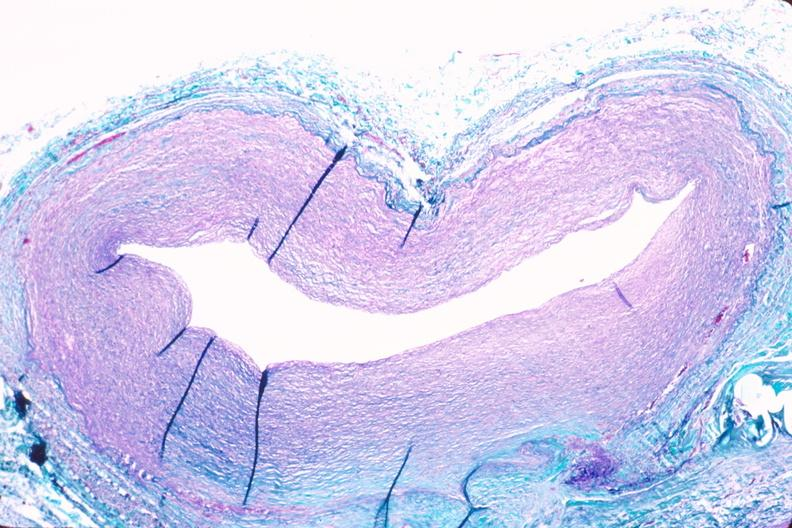does this image show saphenous vein graft sclerosis?
Answer the question using a single word or phrase. Yes 